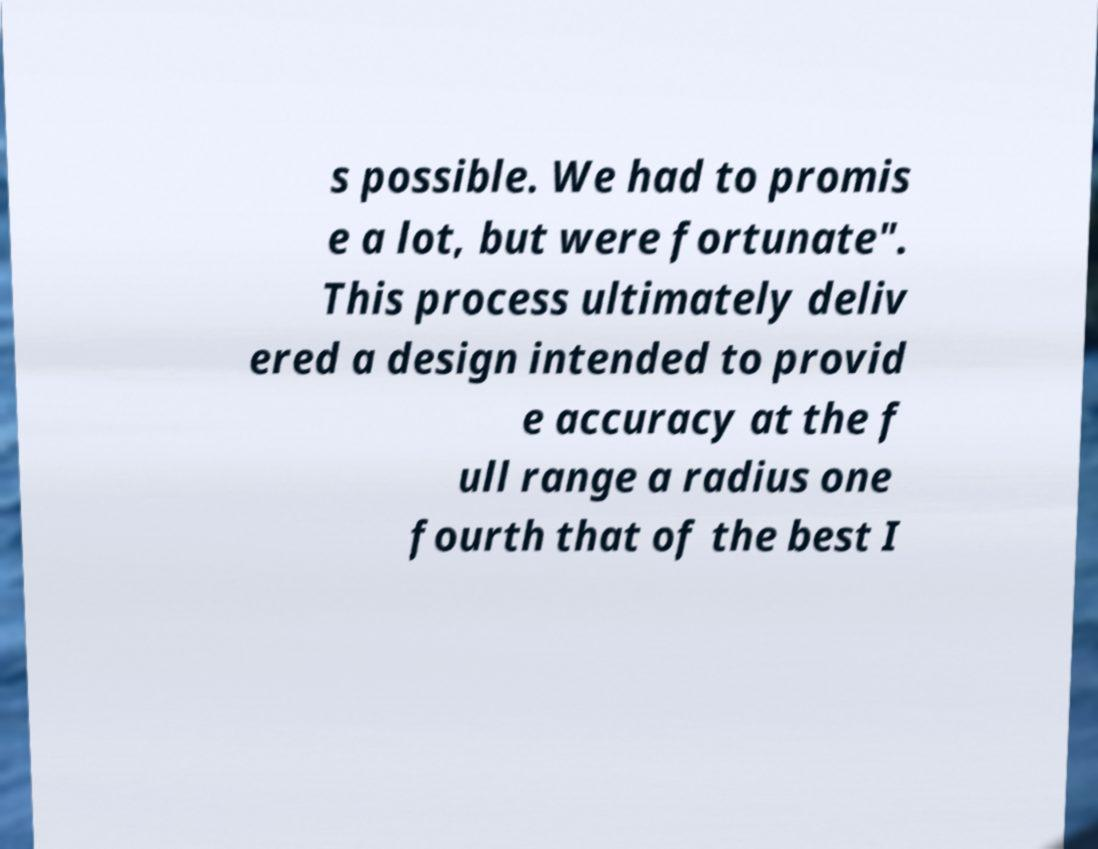For documentation purposes, I need the text within this image transcribed. Could you provide that? s possible. We had to promis e a lot, but were fortunate". This process ultimately deliv ered a design intended to provid e accuracy at the f ull range a radius one fourth that of the best I 